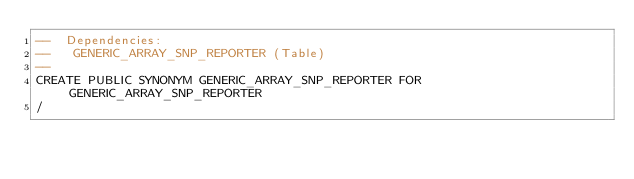Convert code to text. <code><loc_0><loc_0><loc_500><loc_500><_SQL_>--  Dependencies: 
--   GENERIC_ARRAY_SNP_REPORTER (Table)
--
CREATE PUBLIC SYNONYM GENERIC_ARRAY_SNP_REPORTER FOR GENERIC_ARRAY_SNP_REPORTER
/


</code> 